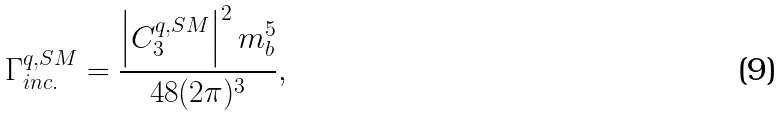<formula> <loc_0><loc_0><loc_500><loc_500>\Gamma ^ { q , S M } _ { i n c . } = \frac { \left | C _ { 3 } ^ { q , S M } \right | ^ { 2 } m _ { b } ^ { 5 } } { 4 8 ( 2 \pi ) ^ { 3 } } ,</formula> 